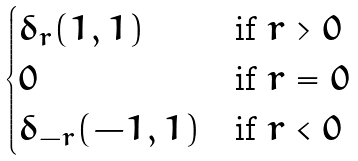<formula> <loc_0><loc_0><loc_500><loc_500>\begin{cases} \delta _ { r } ( 1 , 1 ) & \text {if } r > 0 \\ 0 & \text {if } r = 0 \\ \delta _ { - r } ( - 1 , 1 ) & \text {if } r < 0 \end{cases}</formula> 